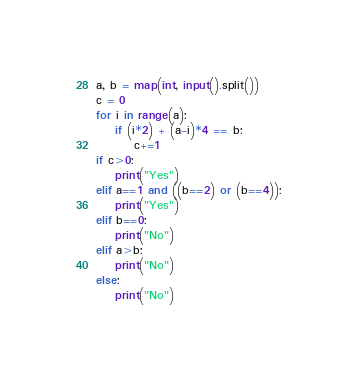<code> <loc_0><loc_0><loc_500><loc_500><_Python_>a, b = map(int, input().split())
c = 0
for i in range(a):
    if (i*2) + (a-i)*4 == b:
        c+=1
if c>0:
    print("Yes")
elif a==1 and ((b==2) or (b==4)):
    print("Yes")
elif b==0:
    print("No")
elif a>b:
    print("No")
else:
    print("No") </code> 